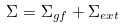<formula> <loc_0><loc_0><loc_500><loc_500>\Sigma = \Sigma _ { g f } + \Sigma _ { e x t }</formula> 